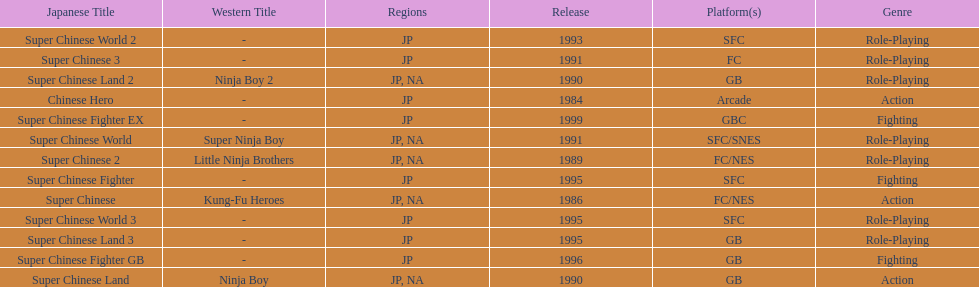The first year a game was released in north america 1986. 